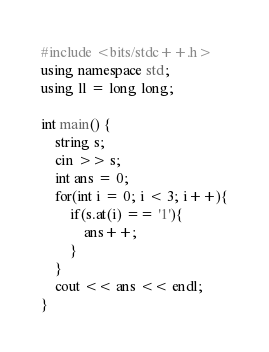<code> <loc_0><loc_0><loc_500><loc_500><_C++_>#include <bits/stdc++.h>
using namespace std;
using ll = long long;

int main() {
    string s;
    cin >> s;
    int ans = 0;
    for(int i = 0; i < 3; i++){
        if(s.at(i) == '1'){
            ans++;
        }
    }
    cout << ans << endl;
}</code> 